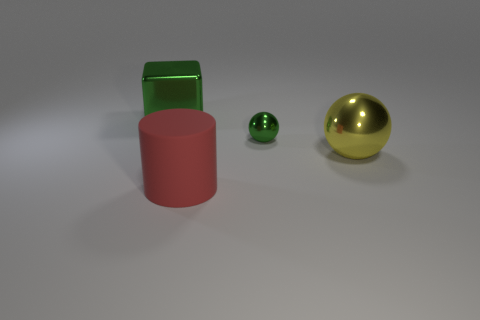Subtract 0 red balls. How many objects are left? 4 Subtract all cubes. How many objects are left? 3 Subtract 2 balls. How many balls are left? 0 Subtract all purple spheres. Subtract all green cylinders. How many spheres are left? 2 Subtract all blue cubes. How many yellow spheres are left? 1 Subtract all big yellow matte balls. Subtract all large things. How many objects are left? 1 Add 3 large red cylinders. How many large red cylinders are left? 4 Add 3 small red cylinders. How many small red cylinders exist? 3 Add 3 balls. How many objects exist? 7 Subtract all green spheres. How many spheres are left? 1 